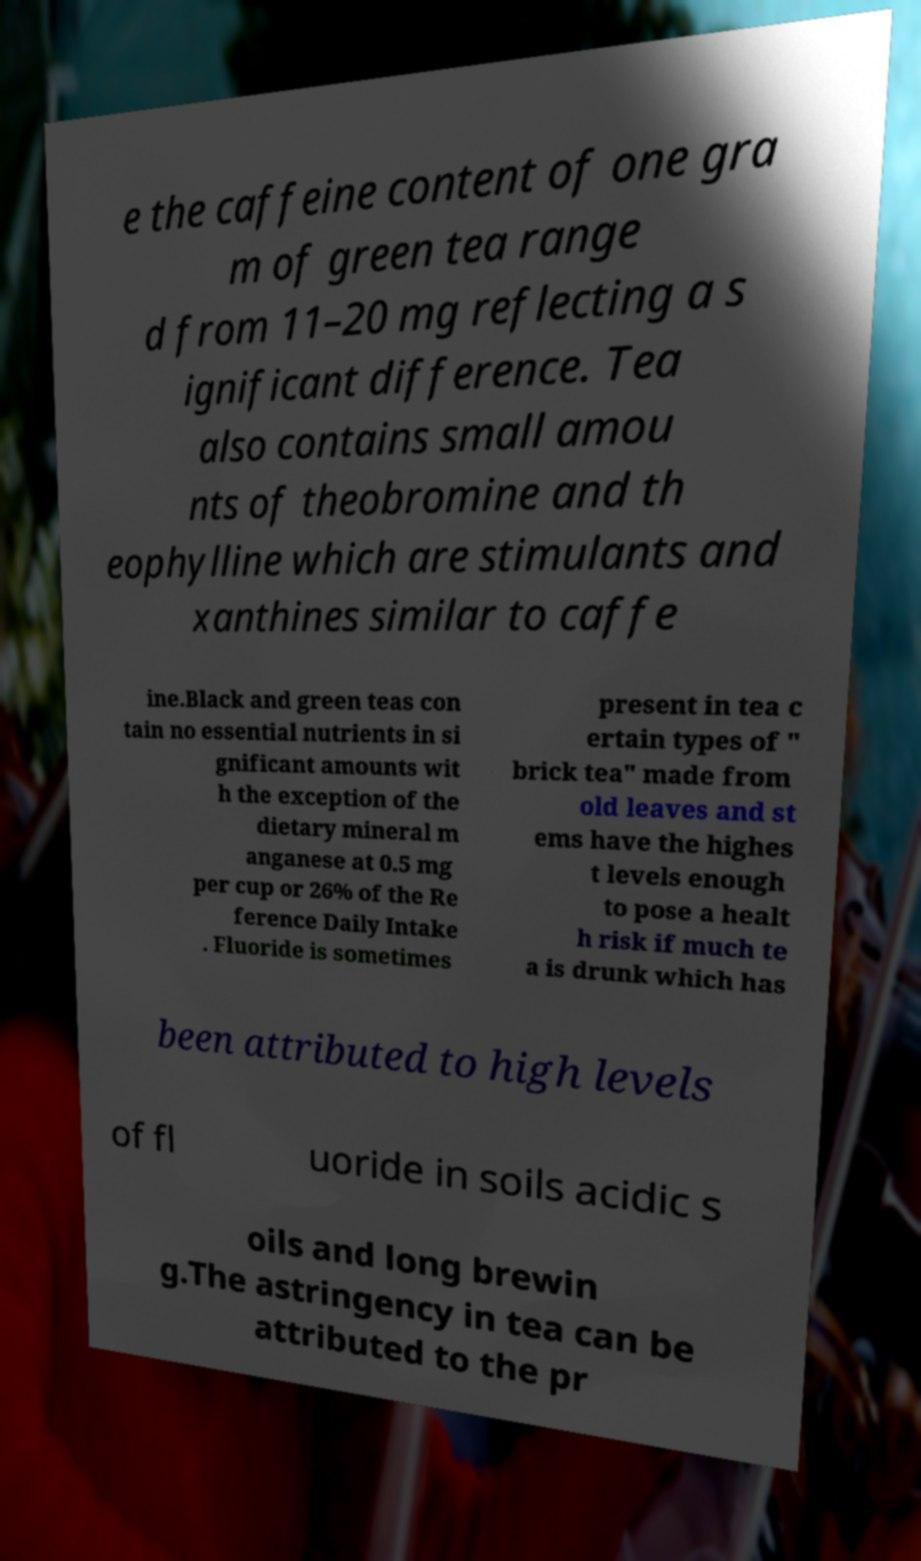What messages or text are displayed in this image? I need them in a readable, typed format. e the caffeine content of one gra m of green tea range d from 11–20 mg reflecting a s ignificant difference. Tea also contains small amou nts of theobromine and th eophylline which are stimulants and xanthines similar to caffe ine.Black and green teas con tain no essential nutrients in si gnificant amounts wit h the exception of the dietary mineral m anganese at 0.5 mg per cup or 26% of the Re ference Daily Intake . Fluoride is sometimes present in tea c ertain types of " brick tea" made from old leaves and st ems have the highes t levels enough to pose a healt h risk if much te a is drunk which has been attributed to high levels of fl uoride in soils acidic s oils and long brewin g.The astringency in tea can be attributed to the pr 